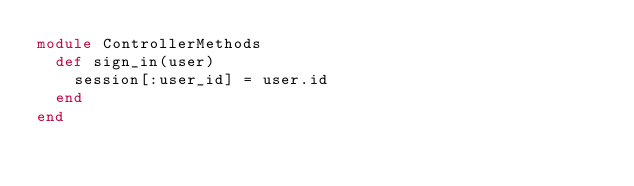Convert code to text. <code><loc_0><loc_0><loc_500><loc_500><_Ruby_>module ControllerMethods
  def sign_in(user)
    session[:user_id] = user.id
  end
end
</code> 